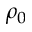Convert formula to latex. <formula><loc_0><loc_0><loc_500><loc_500>\rho _ { 0 }</formula> 